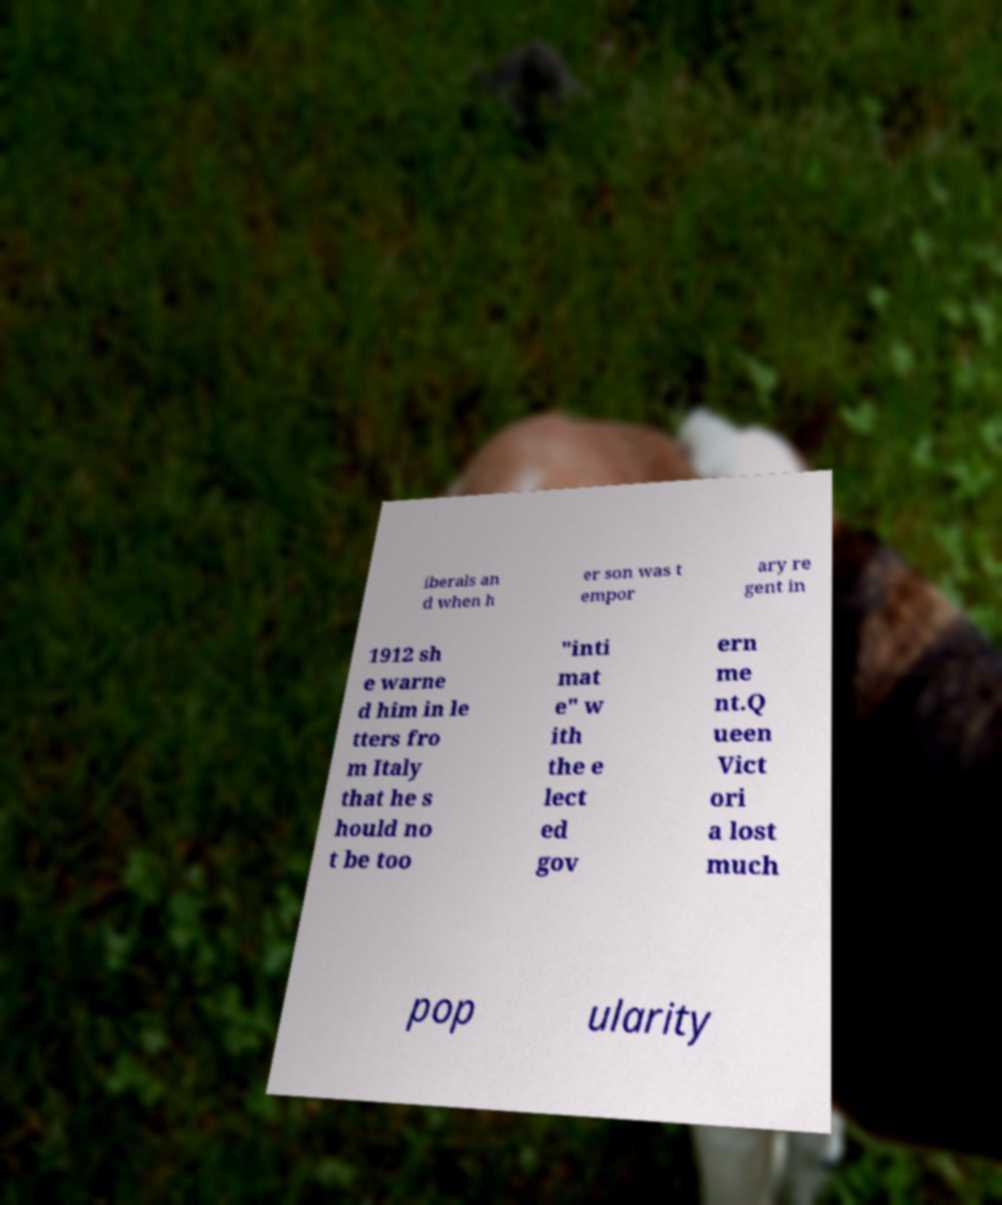Can you read and provide the text displayed in the image?This photo seems to have some interesting text. Can you extract and type it out for me? iberals an d when h er son was t empor ary re gent in 1912 sh e warne d him in le tters fro m Italy that he s hould no t be too "inti mat e" w ith the e lect ed gov ern me nt.Q ueen Vict ori a lost much pop ularity 